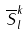<formula> <loc_0><loc_0><loc_500><loc_500>\overline { S } _ { l } ^ { k }</formula> 